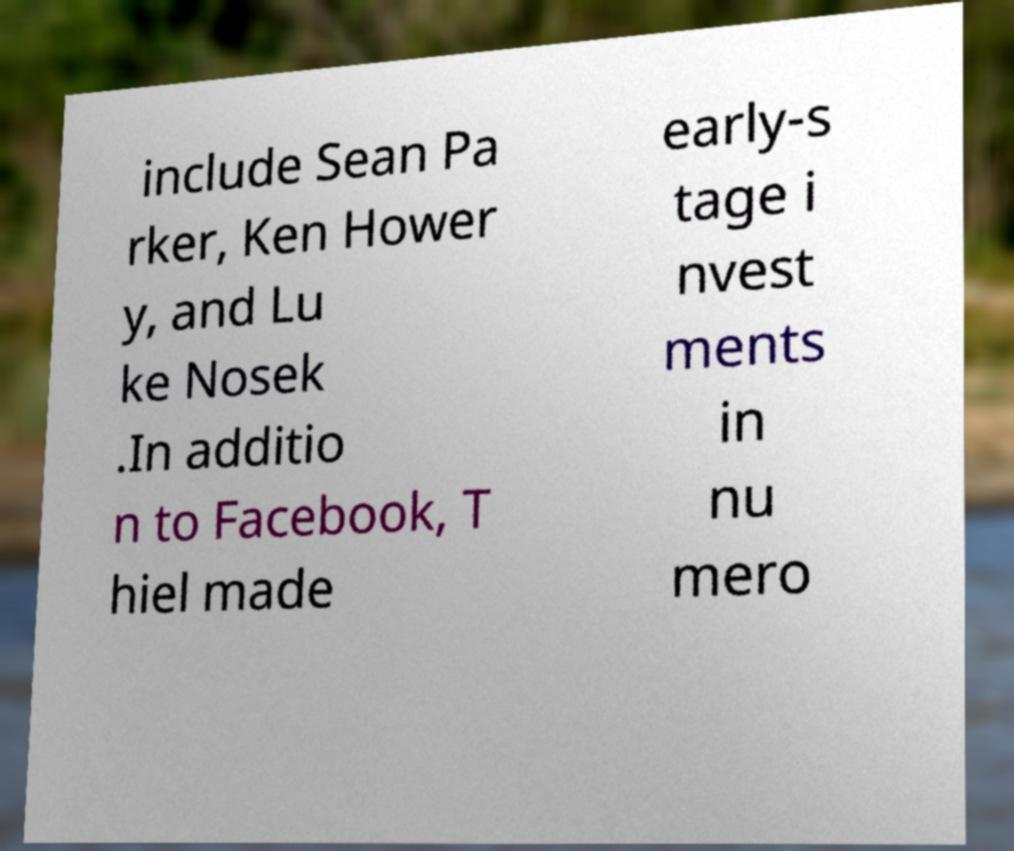What messages or text are displayed in this image? I need them in a readable, typed format. include Sean Pa rker, Ken Hower y, and Lu ke Nosek .In additio n to Facebook, T hiel made early-s tage i nvest ments in nu mero 